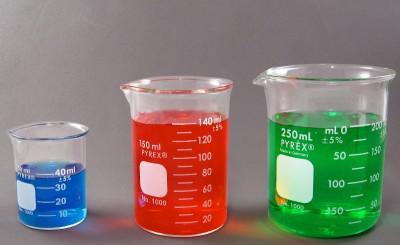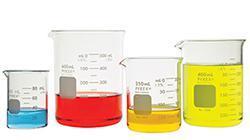The first image is the image on the left, the second image is the image on the right. Assess this claim about the two images: "There are two beakers with red liquid in them.". Correct or not? Answer yes or no. Yes. The first image is the image on the left, the second image is the image on the right. Considering the images on both sides, is "There are three beakers on the left, filled with red, blue, and green liquid." valid? Answer yes or no. Yes. 